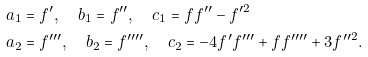Convert formula to latex. <formula><loc_0><loc_0><loc_500><loc_500>a _ { 1 } & = f ^ { \prime } , \quad b _ { 1 } = f ^ { \prime \prime } , \quad c _ { 1 } = f f ^ { \prime \prime } - f ^ { \prime 2 } \\ a _ { 2 } & = f ^ { \prime \prime \prime } , \quad b _ { 2 } = f ^ { \prime \prime \prime \prime } , \quad c _ { 2 } = - 4 f ^ { \prime } f ^ { \prime \prime \prime } + f f ^ { \prime \prime \prime \prime } + 3 f ^ { \prime \prime 2 } .</formula> 